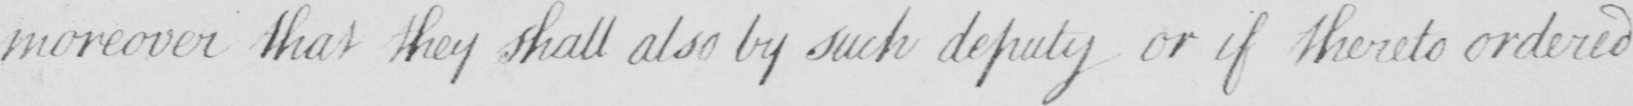Can you read and transcribe this handwriting? moreover that they shall also by such deputy or if thereto ordered 